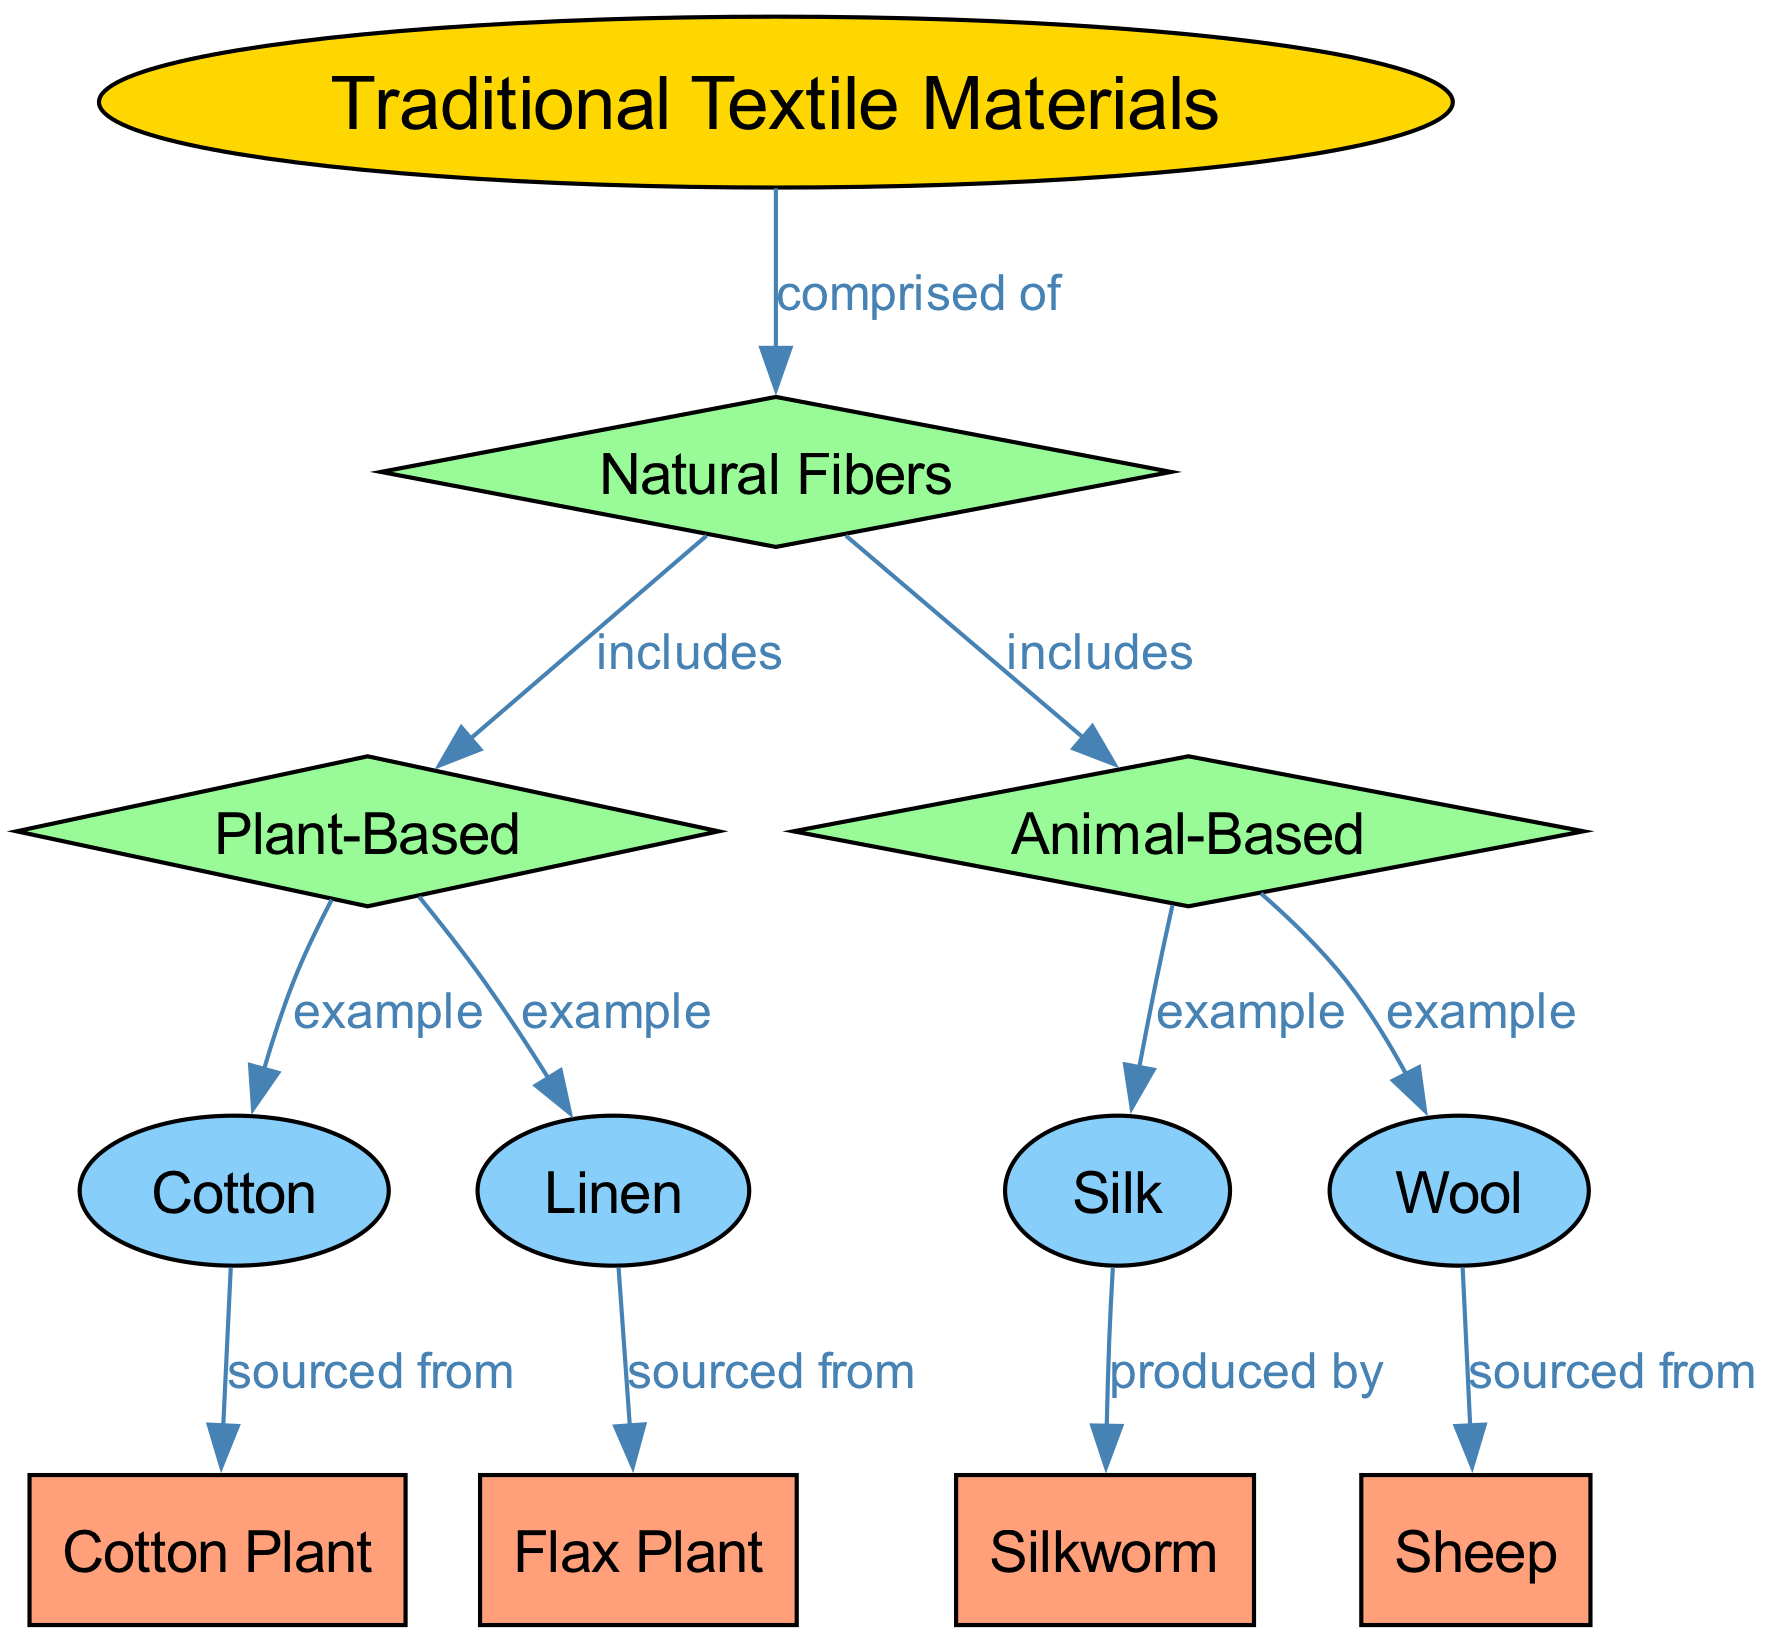What are the two main categories of natural fibers? In the diagram, the "natural fibers" node branches out into two categories: "plant-based" and "animal-based." This clearly shows that these are the two main groupings for natural fibers.
Answer: plant-based, animal-based How many examples of plant-based fibers are listed? The "plant-based" node connects to two examples: "cotton" and "linen." Counting these, we find that there are two examples provided.
Answer: 2 Which animal produces wool? From the diagram, the "wool" node is connected to "sheep," indicating that wool is sourced from sheep.
Answer: Sheep What type of plant is cotton sourced from? The diagram shows that the "cotton" node is linked to "cotton plant," identifying this specific plant as the source of cotton.
Answer: Cotton Plant How many edges connect the traditional textiles node to other categories? The "traditional textiles" node has one edge that goes to "natural fibers." Since this is the only connection, the count is one.
Answer: 1 What is the relationship between silk and its source? The "silk" node is directly linked to the "silkworm" node with the label "produced by," indicating that silkworms are the source of silk.
Answer: Produced by Are all examples of textiles listed in the same category? The examples of textiles, cotton, linen, silk, and wool, are found under two distinct categories: plant-based and animal-based. Hence, they are not all in the same category.
Answer: No Which fiber is an example of animal-based textile? The "animal-based" node connects to "silk" and "wool." Both are examples of animal-based textiles, but since the question asks for one example, either can be named.
Answer: Silk What distinguishes natural fibers from traditional textiles? The diagram states that "traditional textiles" are comprised of "natural fibers." This suggests that natural fibers make up traditional textiles, highlighting the difference by establishing a foundational relationship.
Answer: Comprised of What are the sources for linen? The "linen" node in the diagram is linked to "flax plant," indicating that linen is sourced from the flax plant.
Answer: Flax Plant 